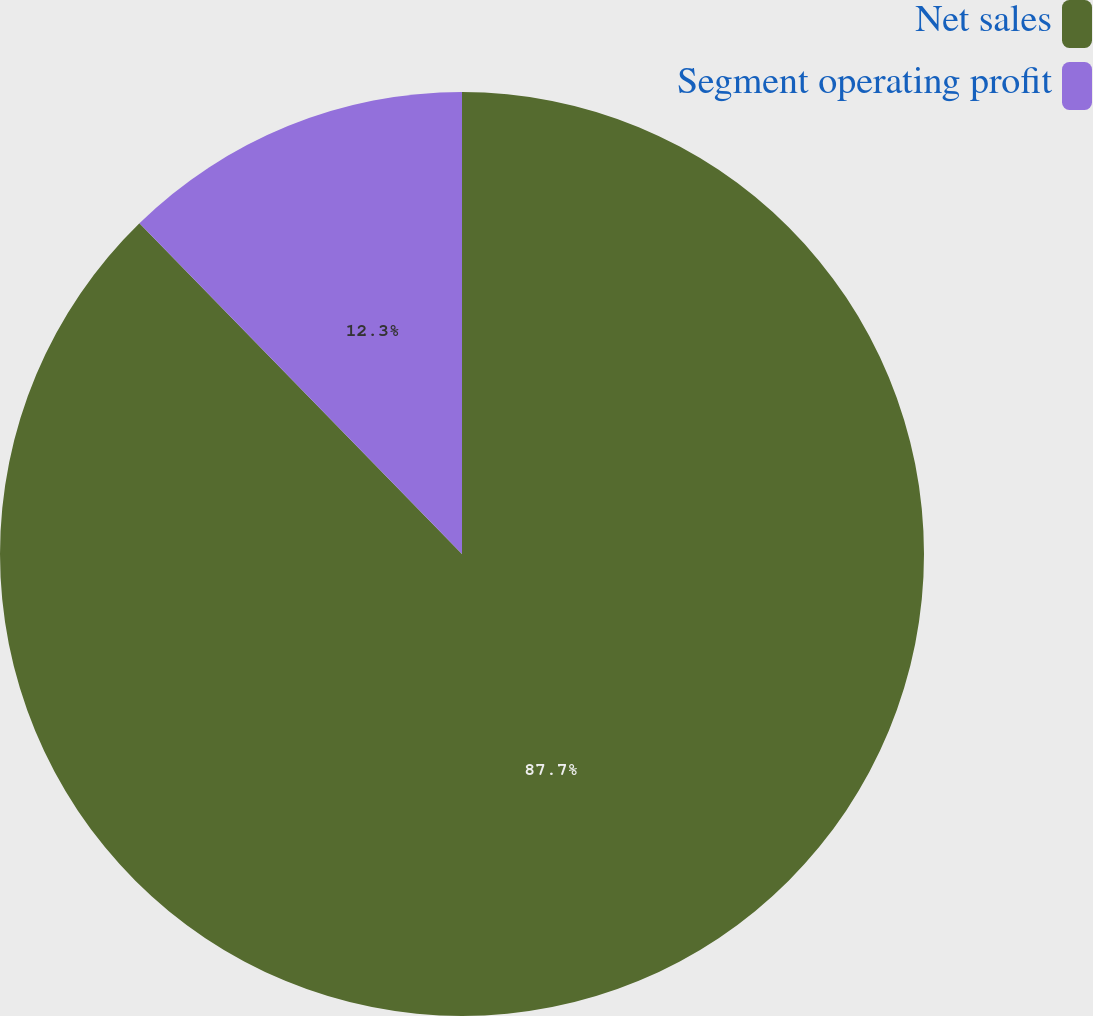Convert chart. <chart><loc_0><loc_0><loc_500><loc_500><pie_chart><fcel>Net sales<fcel>Segment operating profit<nl><fcel>87.7%<fcel>12.3%<nl></chart> 